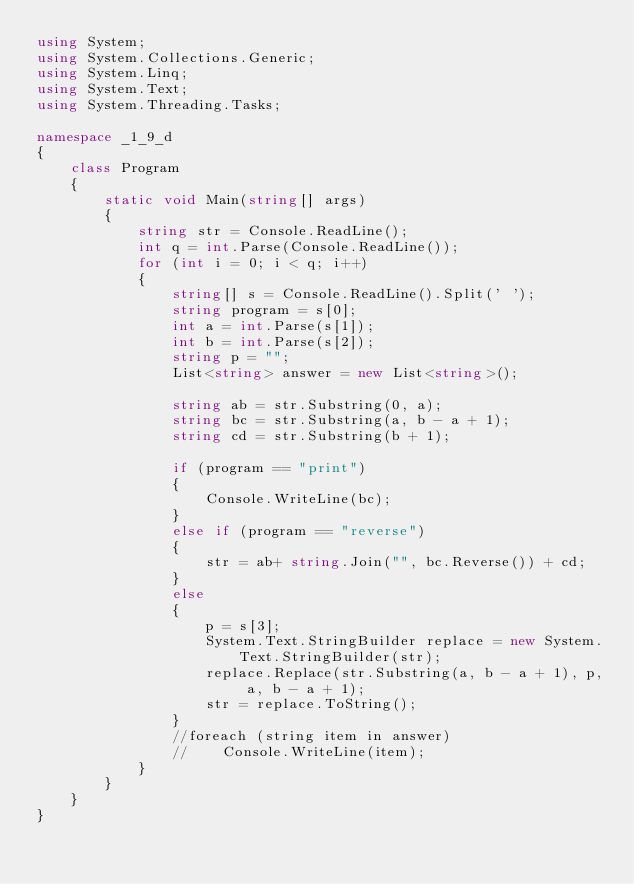Convert code to text. <code><loc_0><loc_0><loc_500><loc_500><_C#_>using System;
using System.Collections.Generic;
using System.Linq;
using System.Text;
using System.Threading.Tasks;

namespace _1_9_d
{
    class Program
    {
        static void Main(string[] args)
        {
            string str = Console.ReadLine();
            int q = int.Parse(Console.ReadLine());
            for (int i = 0; i < q; i++)
            {
                string[] s = Console.ReadLine().Split(' ');
                string program = s[0];
                int a = int.Parse(s[1]);
                int b = int.Parse(s[2]);
                string p = "";
                List<string> answer = new List<string>();

                string ab = str.Substring(0, a);
                string bc = str.Substring(a, b - a + 1);
                string cd = str.Substring(b + 1);

                if (program == "print")
                {
                    Console.WriteLine(bc);
                }
                else if (program == "reverse")
                {
                    str = ab+ string.Join("", bc.Reverse()) + cd;
                }
                else
                {
                    p = s[3];
                    System.Text.StringBuilder replace = new System.Text.StringBuilder(str);
                    replace.Replace(str.Substring(a, b - a + 1), p, a, b - a + 1);
                    str = replace.ToString();
                }
                //foreach (string item in answer)
                //    Console.WriteLine(item);
            }
        }
    }
}

</code> 